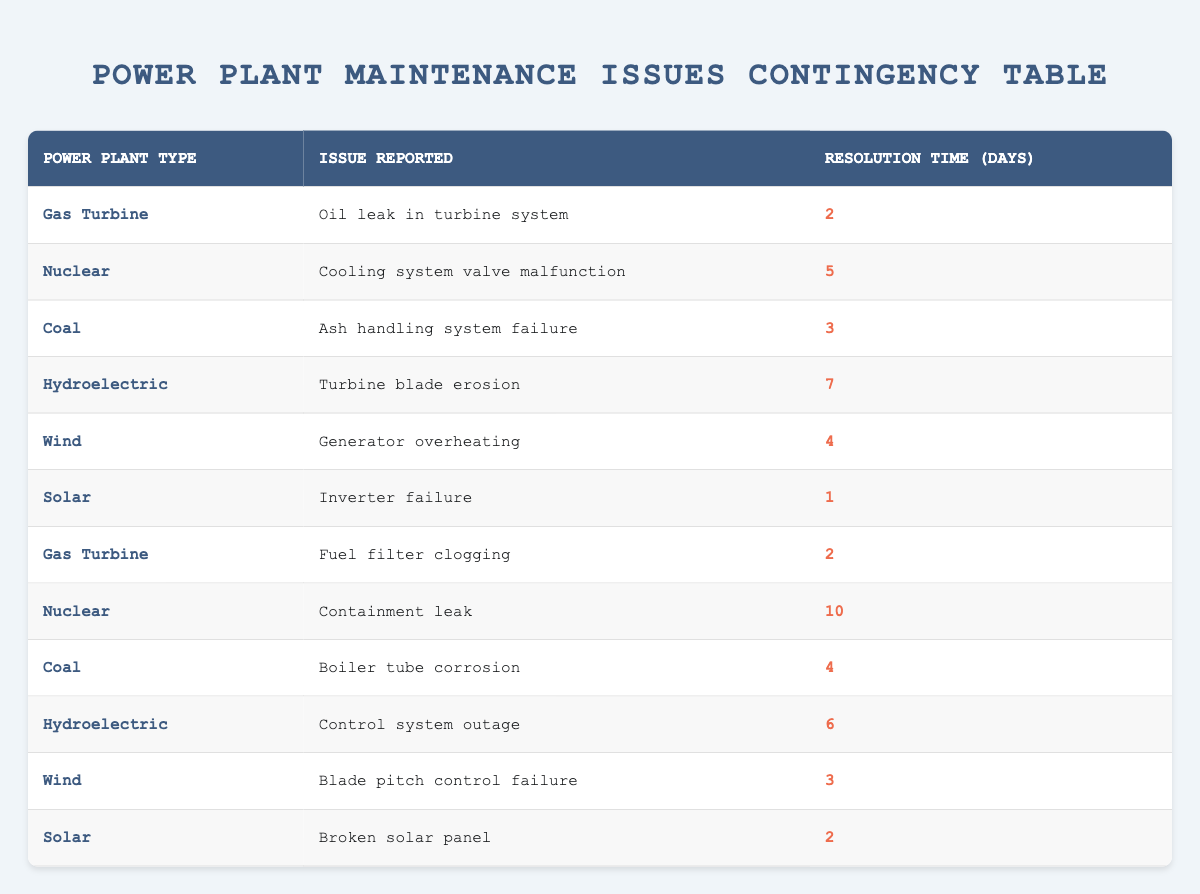What is the resolution time for the "Inverter failure" issue in the Solar power plant? Looking for the row where the power plant type is "Solar" and the issue reported is "Inverter failure", we find that the corresponding resolution time is 1 day.
Answer: 1 Which power plant type had the longest resolution time, and what was the issue? Scanning the table for the highest resolution time, "Containment leak" in the Nuclear plant has the longest resolution time of 10 days.
Answer: Nuclear, Containment leak How many total maintenance issues were reported for Coal power plants? Filtering the table for the Coal power plant type, we see two issues reported: "Ash handling system failure" and "Boiler tube corrosion", making a total of 2 issues.
Answer: 2 What is the average resolution time for the maintenance issues reported across all power plant types? To calculate the average, add up the resolution times: (2 + 5 + 3 + 7 + 4 + 1 + 2 + 10 + 4 + 6 + 3 + 2) = 49 days. There are 12 issues, so the average resolution time is 49/12 ≈ 4.08 days.
Answer: 4.08 Is there any maintenance issue reported with a resolution time less than 3 days? Review the table for resolution times, the issues "Inverter failure" (1 day), "Oil leak in turbine system" (2 days), "Fuel filter clogging" (2 days), and "Broken solar panel" (2 days) confirm that there are several issues under 3 days.
Answer: Yes What is the total resolution time for issues reported in Hydroelectric plants? Finding the Hydroelectric plant rows, the resolution times are 7 days for "Turbine blade erosion" and 6 days for "Control system outage"; adding these gives us 13 days total.
Answer: 13 Which issue reported required the least resolution time among all power plant types? Checking each resolution time in the table, the "Inverter failure" issue for Solar power plants required the least time of just 1 day.
Answer: Inverter failure How many issues were reported for Wind power plants? Inspecting the Wind power plant rows shows two issues: "Generator overheating" and "Blade pitch control failure", indicating a total of 2 issues.
Answer: 2 What is the difference in resolution time between the longest (Nuclear plant issues) and the shortest (Solar plant issues)? The longest resolution time is 10 days (Nuclear) for the "Containment leak", while the shortest is 1 day (Solar) for "Inverter failure". The difference is 10 - 1 = 9 days.
Answer: 9 